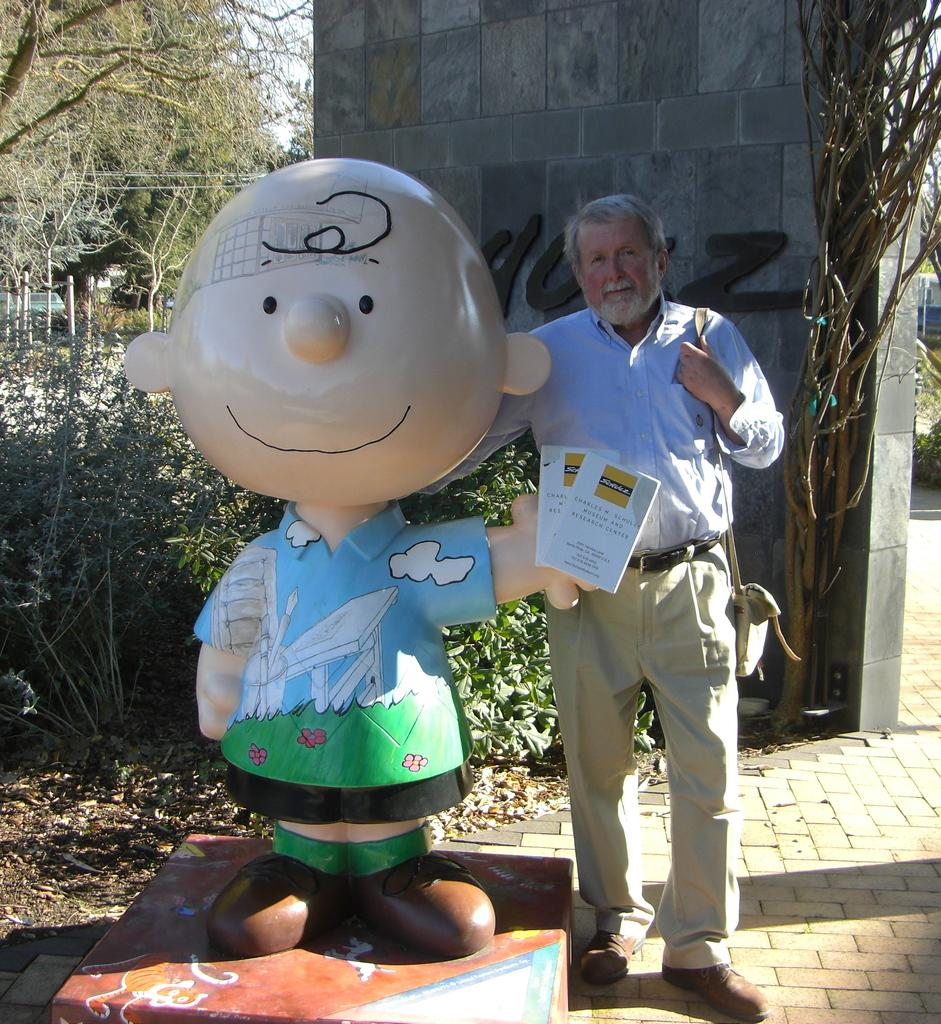What is the man standing beside in the image? The man is standing beside a sculpture. What can be seen in the background of the image? There is a wall and trees in the background. What type of meal is being served on the clock in the image? There is no clock or meal present in the image. What emotion does the man feel while standing beside the sculpture in the image? The image does not provide information about the man's emotions, so we cannot determine his feelings from the image. 